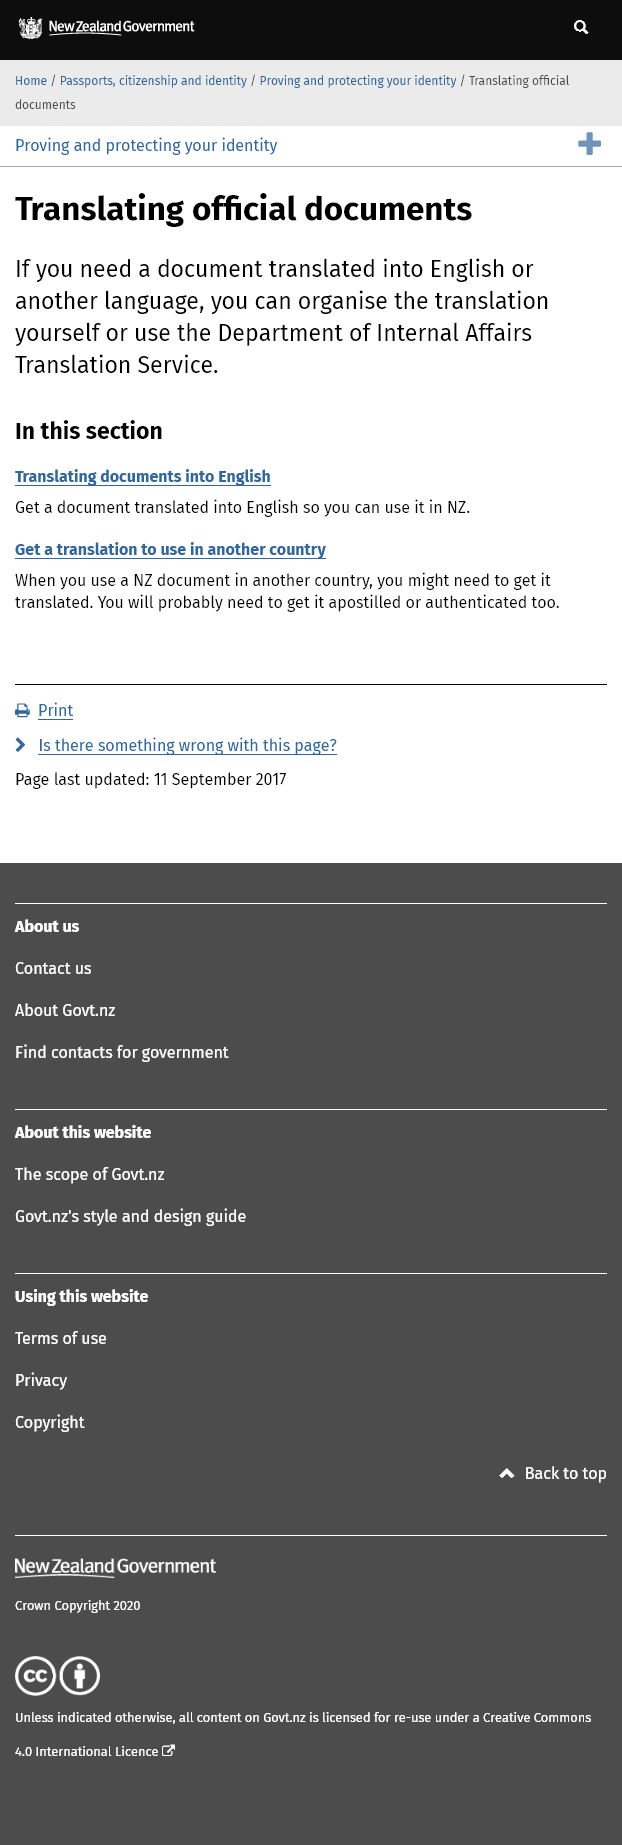Identify some key points in this picture. When using a New Zealand document in another country, factors such as translation, apostille, or authentication may need to be considered to ensure the document's validity and legal recognition in the new country. The role of the Department of International Affairs is to translate documents into English or other languages in order to facilitate communication and understanding between various entities. The translation service provided by the department of international affairs can assist you in obtaining official documents that have been accurately rendered into your preferred language. 